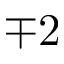Convert formula to latex. <formula><loc_0><loc_0><loc_500><loc_500>\mp 2</formula> 